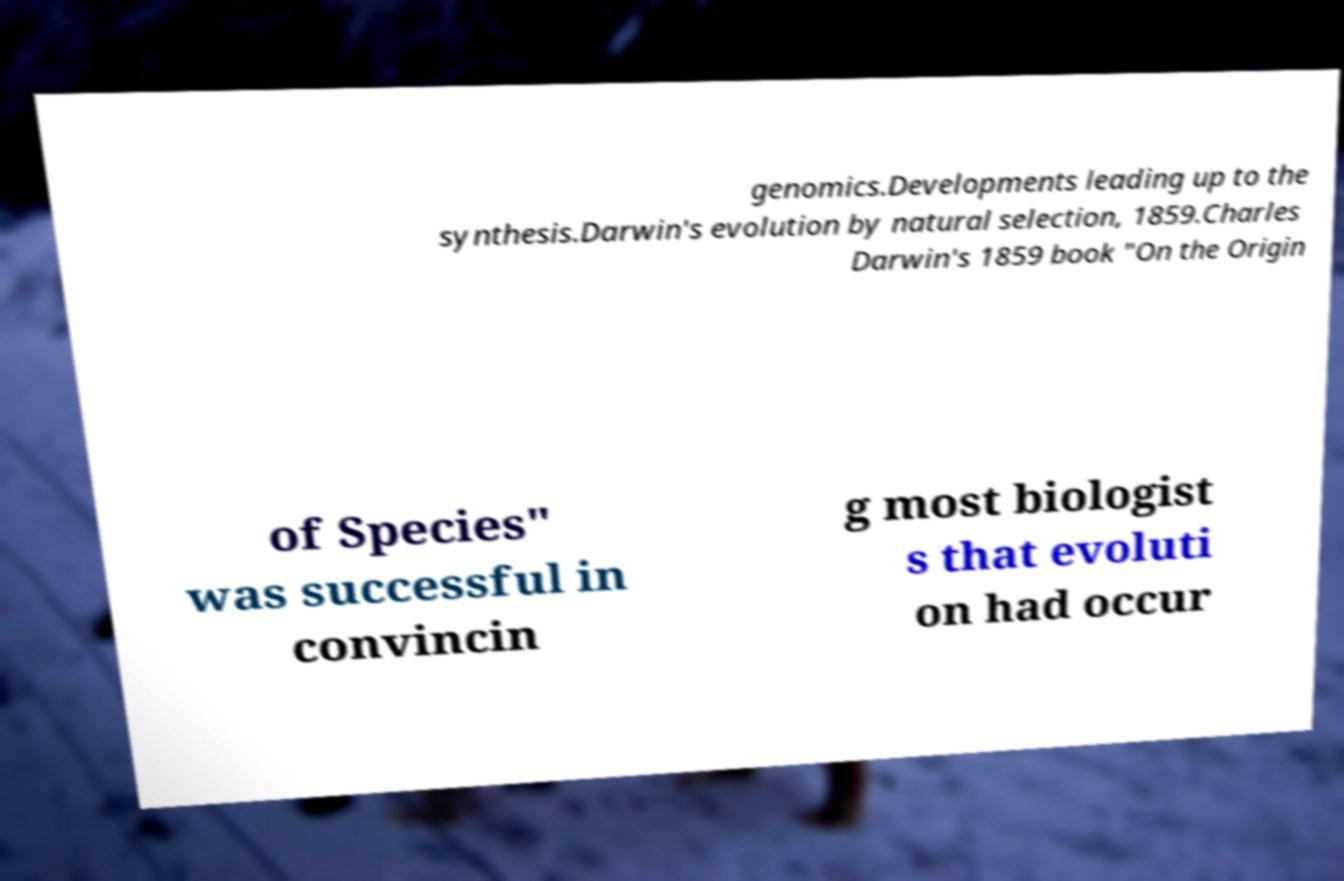Could you assist in decoding the text presented in this image and type it out clearly? genomics.Developments leading up to the synthesis.Darwin's evolution by natural selection, 1859.Charles Darwin's 1859 book "On the Origin of Species" was successful in convincin g most biologist s that evoluti on had occur 